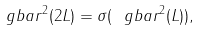Convert formula to latex. <formula><loc_0><loc_0><loc_500><loc_500>\ g b a r ^ { 2 } ( 2 L ) = \sigma ( \ g b a r ^ { 2 } ( L ) ) ,</formula> 